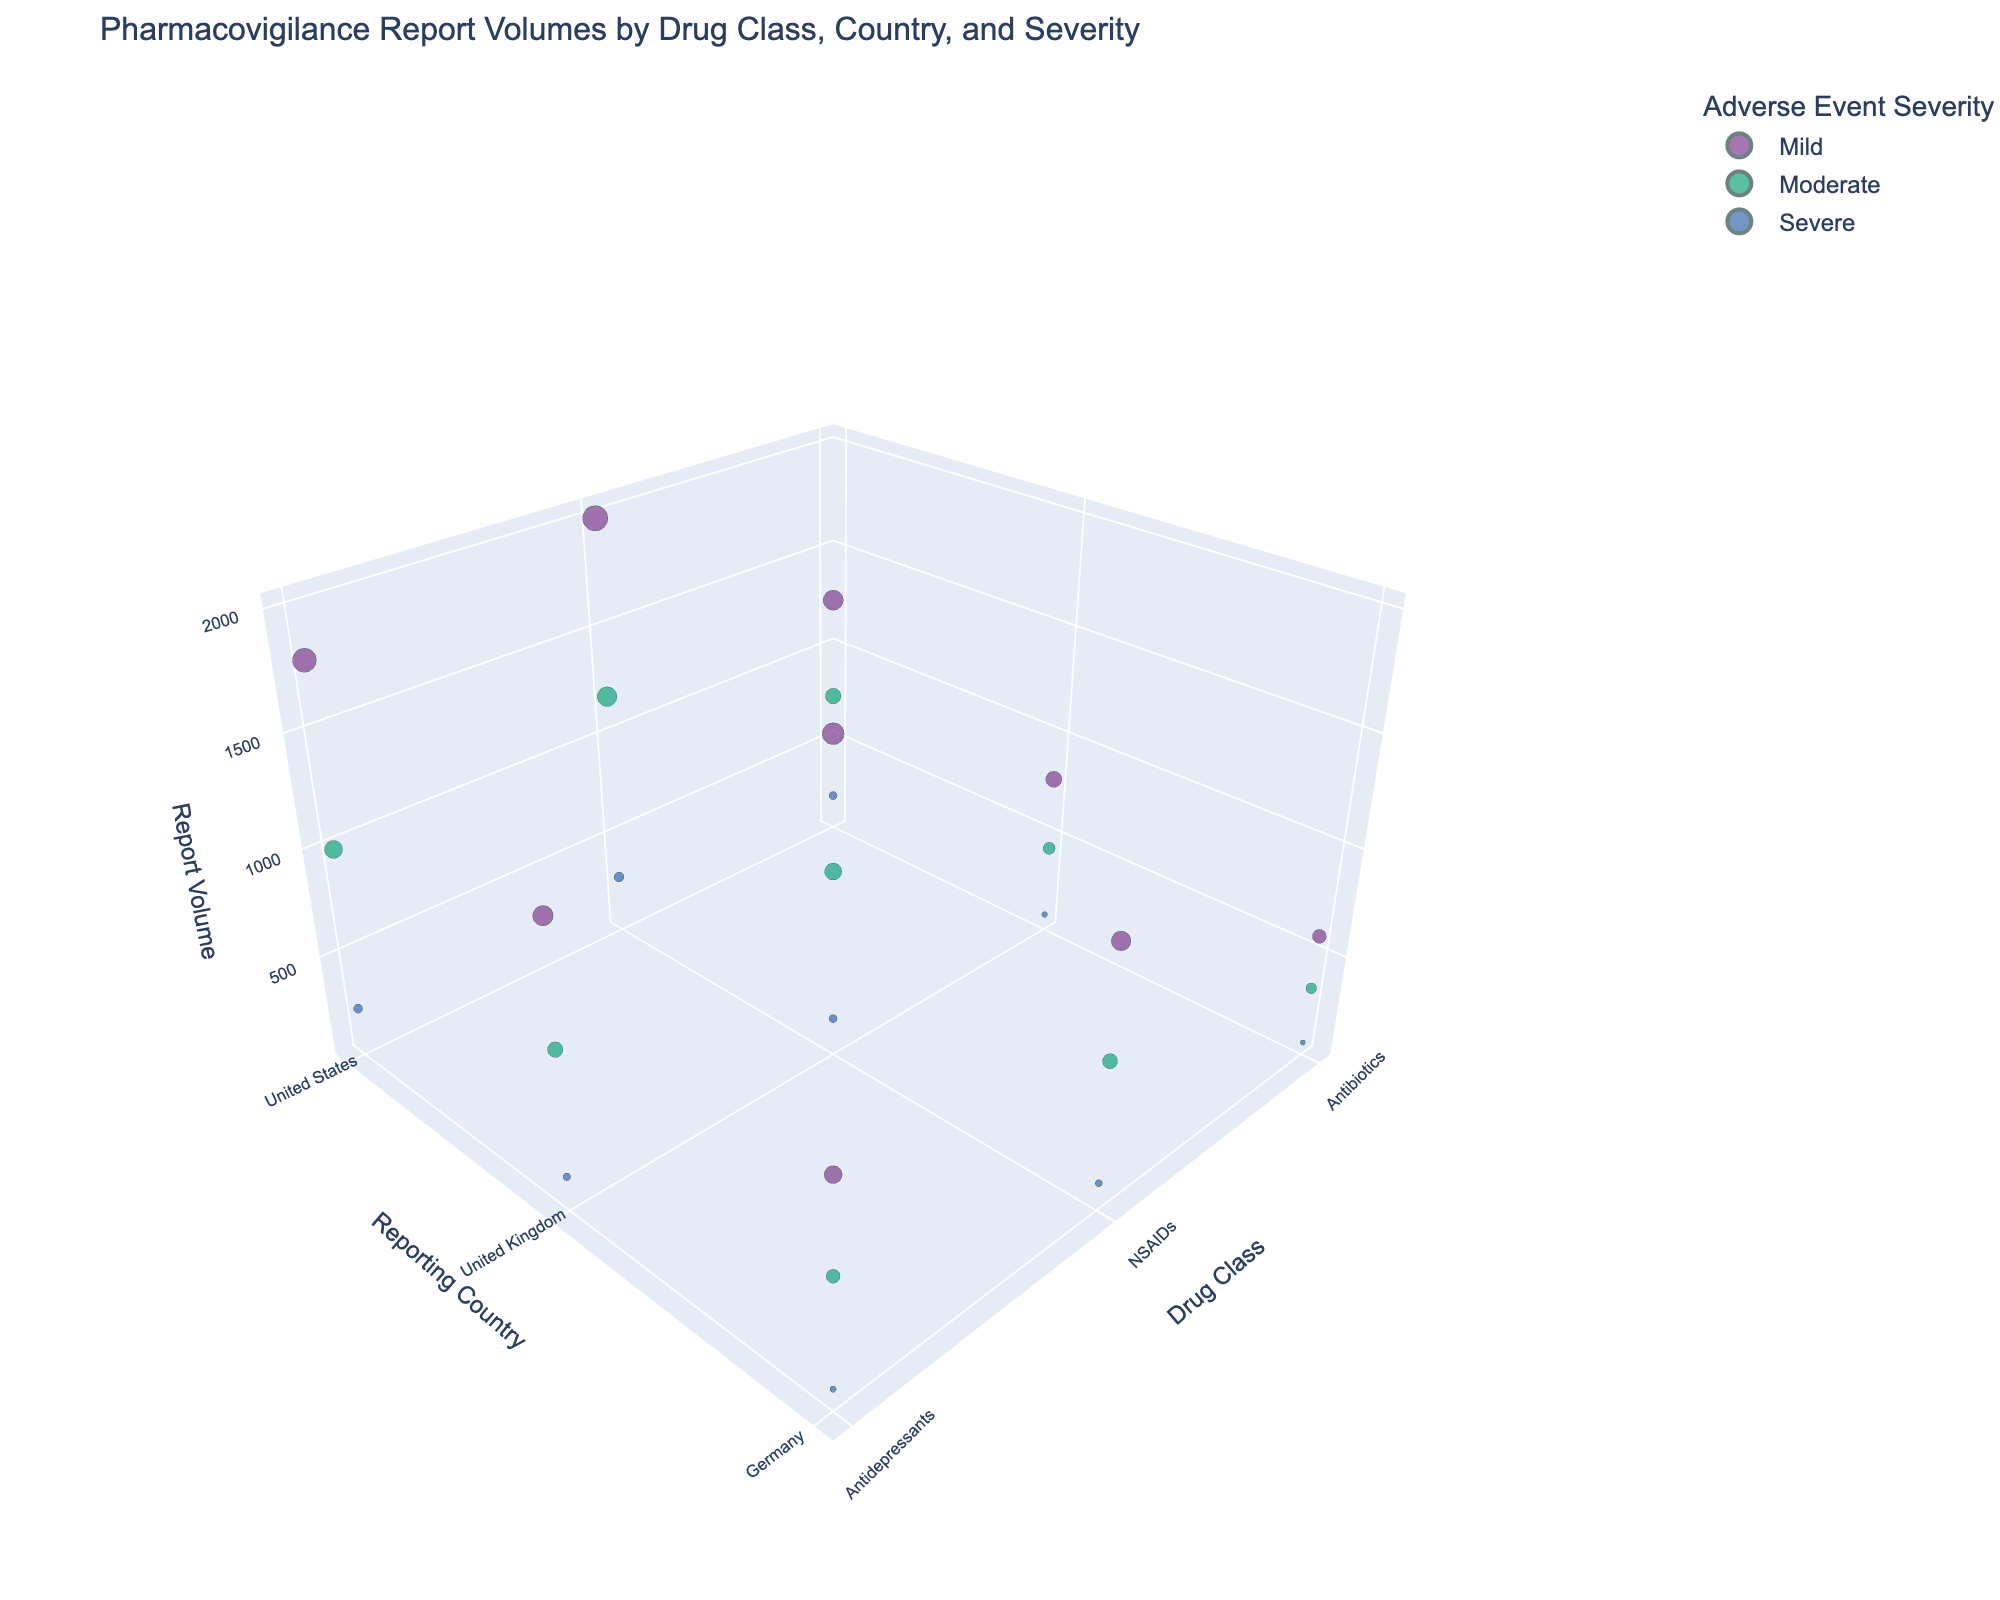What's the title of the plot? The title of the plot is displayed at the top of the figure.
Answer: Pharmacovigilance Report Volumes by Drug Class, Country, and Severity Which country has the highest report volume for NSAIDs with severe adverse events? From the 3D plot, look for the NSAIDs data points color-coded for severe adverse events and compare the report volumes for different countries.
Answer: United States What's the difference in report volume for mild adverse events between NSAIDs in the United States and NSAIDs in the United Kingdom? Locate the data points for mild adverse events for NSAIDs in the United States and the United Kingdom and calculate the difference: 2000 (US) - 1500 (UK).
Answer: 500 Which drug class has the fewest severe adverse event reports in Germany? Identify the data points for severe adverse events in Germany for each drug class and note the one with the smallest report volume.
Answer: Antibiotics How does the report volume of moderate adverse events for Antidepressants in the United Kingdom compare to that in Germany? Find the report volumes for moderate adverse events for Antidepressants in the United Kingdom and Germany, and then compare: 750 (UK) vs. 600 (Germany).
Answer: More in the United Kingdom What is the sum of mild adverse event report volumes for all drug classes in the United Kingdom? Add up the report volumes for mild adverse events in the United Kingdom for all drug classes: 800 (Antibiotics) + 1500 (NSAIDs) + 1300 (Antidepressants).
Answer: 3600 How many different colors are used to represent adverse event severity in the plot? Observe the distinct color categories representing different severities in the legend.
Answer: 3 What is the average report volume for severe adverse events across all drug classes in the United States? Find the report volumes for severe adverse events for each drug class in the United States and calculate the average: (200 + 300 + 250) / 3.
Answer: 250 Which reporting country has the highest total report volume for Antibiotics across all severities? Sum the report volumes for all severities of Antibiotics in each country and identify the highest: 1250 + 750 + 200 (US), 800 + 450 + 100 (UK), 600 + 350 + 80 (Germany).
Answer: United States Between moderate adverse event reports for NSAIDs in the United States and Antidepressants in the United Kingdom, which one is higher? Compare the report volumes for moderate adverse events for NSAIDs in the United States and Antidepressants in the United Kingdom: 1200 vs. 750.
Answer: NSAIDs in the United States 